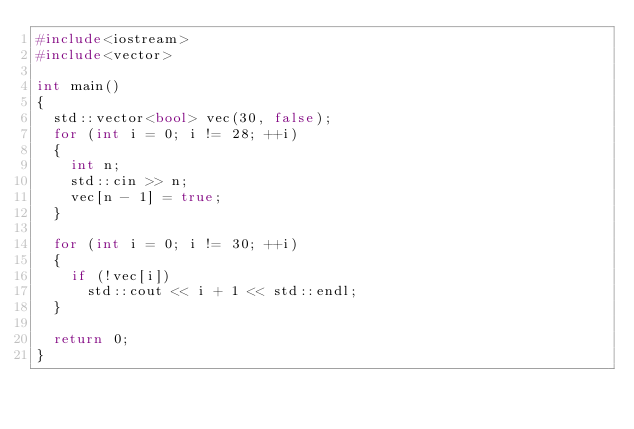Convert code to text. <code><loc_0><loc_0><loc_500><loc_500><_C++_>#include<iostream>
#include<vector>

int main()
{
	std::vector<bool> vec(30, false);
	for (int i = 0; i != 28; ++i)
	{
		int n;
		std::cin >> n;
		vec[n - 1] = true;
	}

	for (int i = 0; i != 30; ++i)
	{
		if (!vec[i])
			std::cout << i + 1 << std::endl;
	}

	return 0;
}</code> 